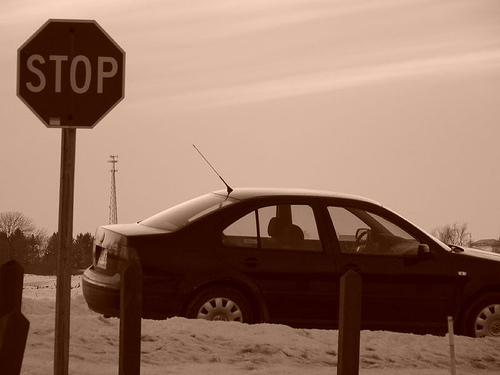Please identify all text content in this image. STOP 